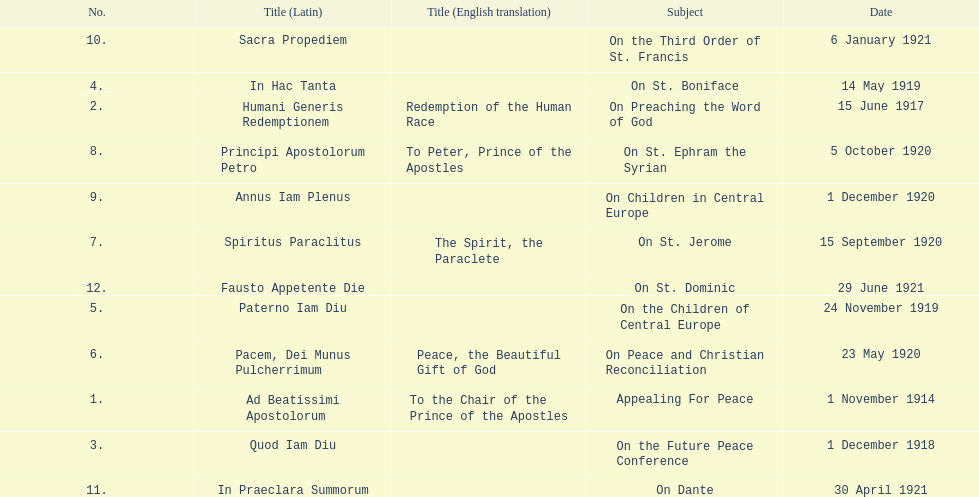What are the number of titles with a date of november? 2. 